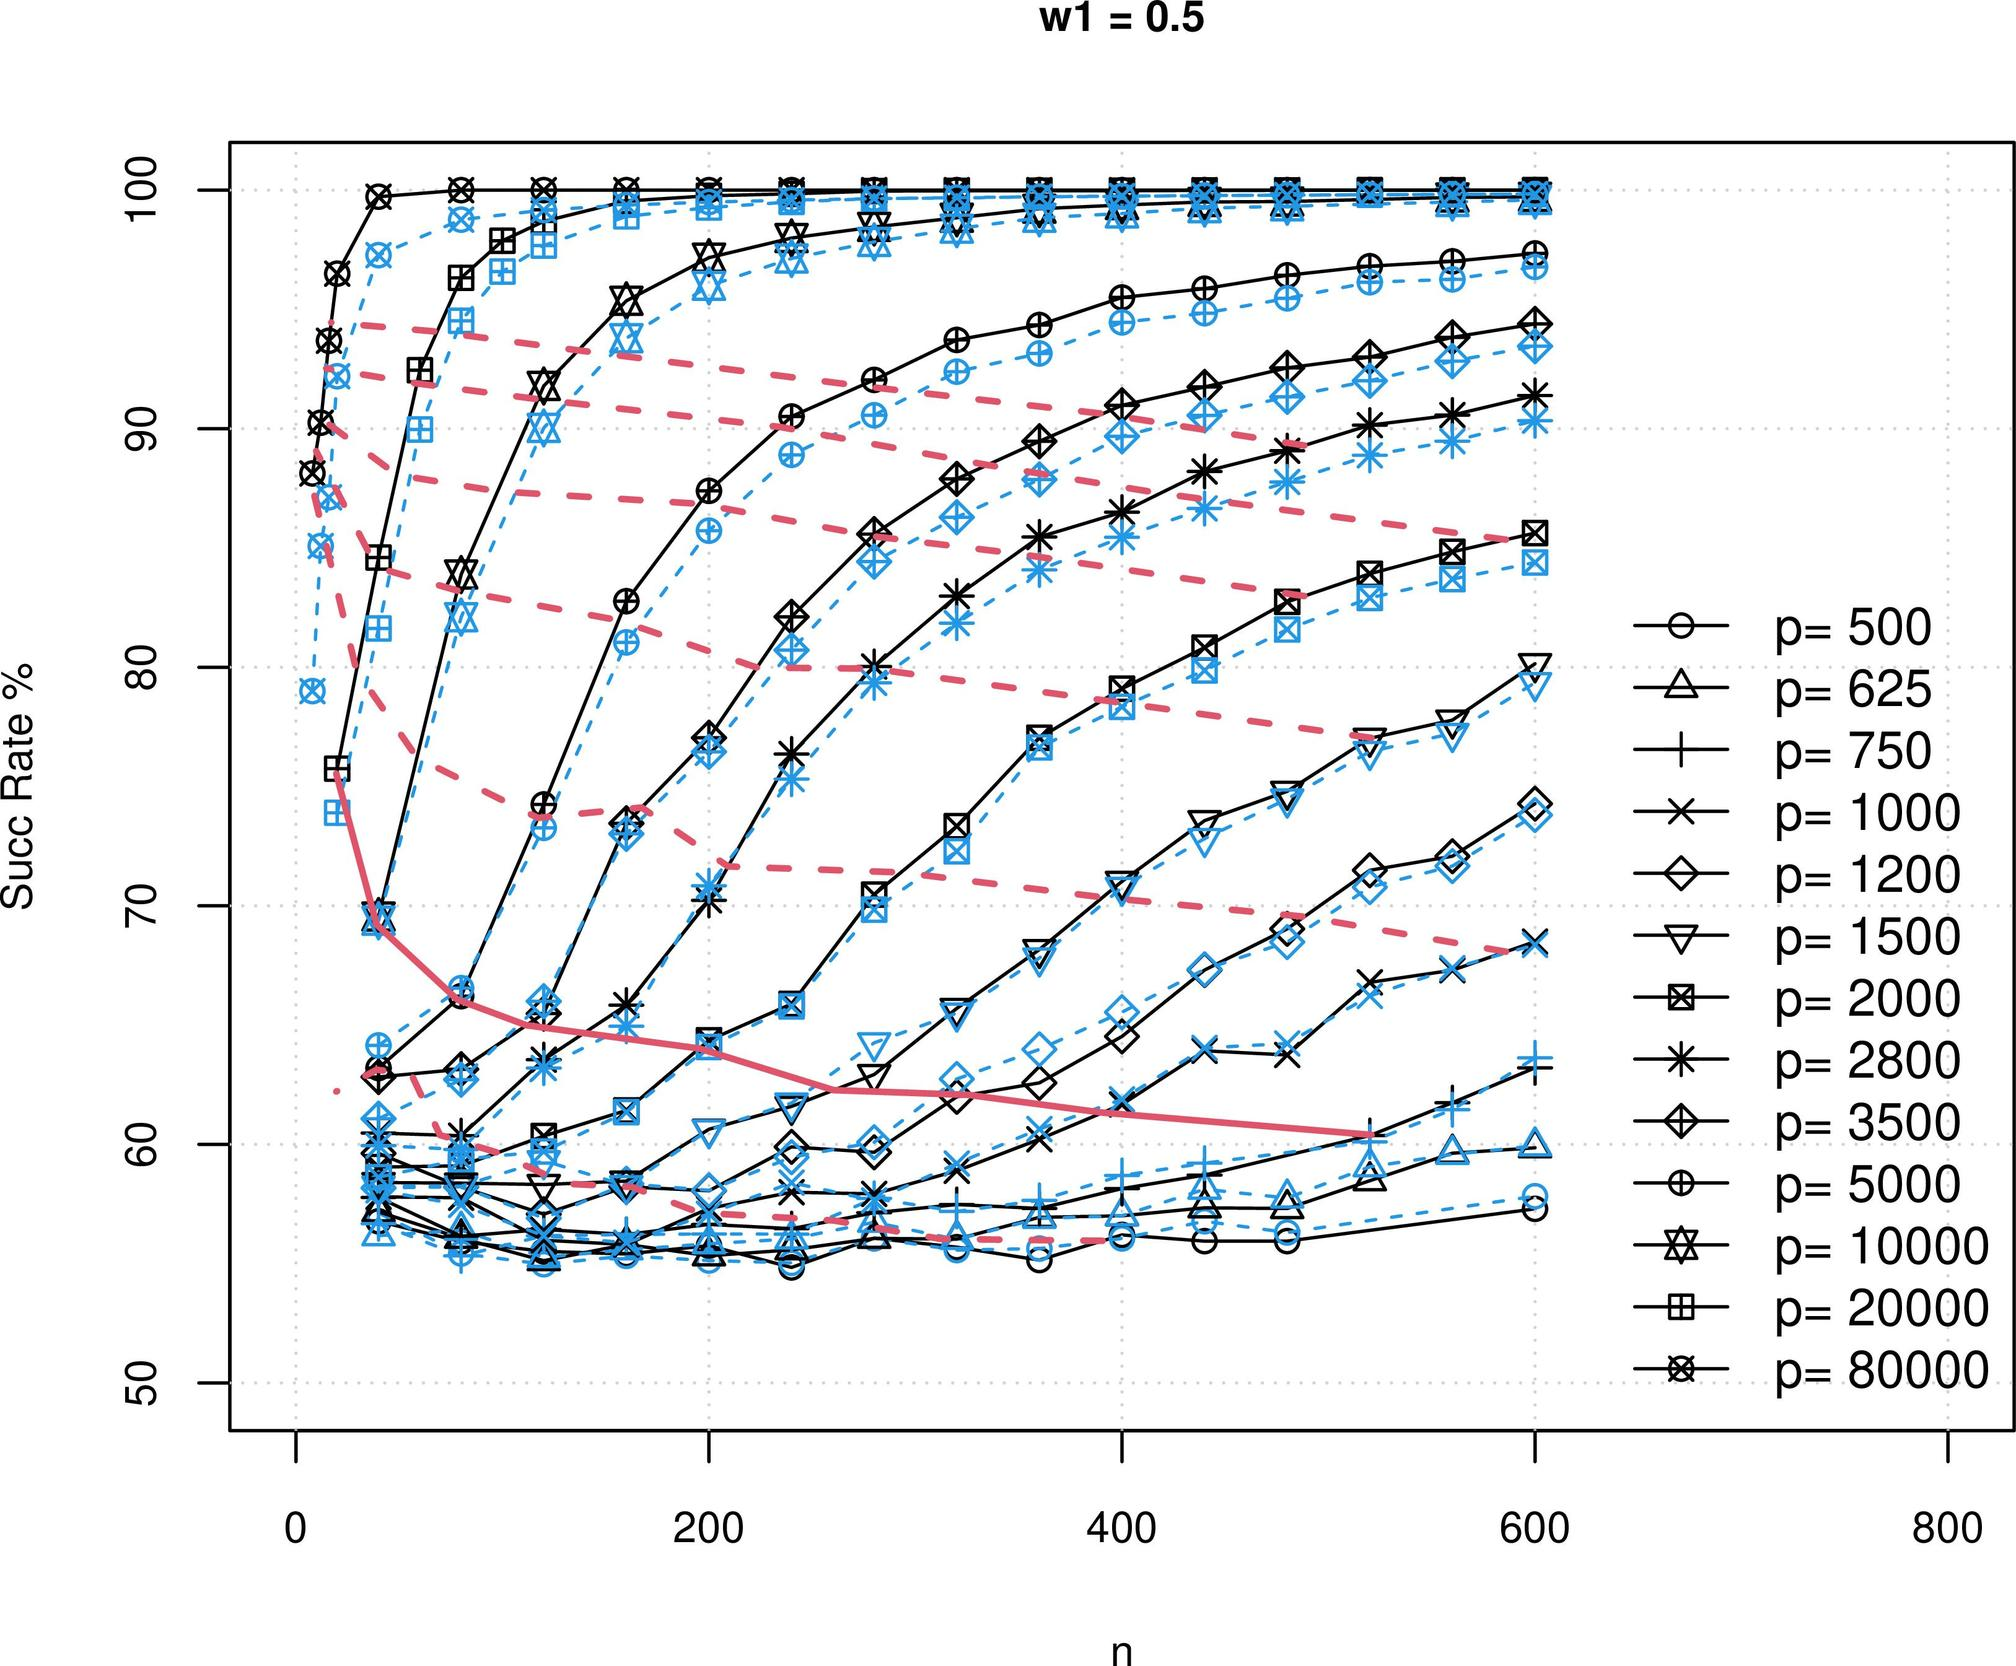Based on the graph, what can be inferred about the relationship between 'n' and the success rate for a fixed 'p' value? A. 'n' and the success rate are inversely proportional. B. 'n' and the success rate are directly proportional. C. 'n' has a sporadic effect on the success rate. D. 'n' does not affect the success rate. The graph presents a clear relation where each series, defined by a constant 'p' value, shows a trend of increasing success rate as 'n' increases. This trend is consistent across the various 'p' values reflected by the differing symbols and lines, indicating a direct proportionality between 'n' and success rate when 'p' is held constant. Therefore, option B is correct, affirming that 'n' and the success rate are directly proportional. 